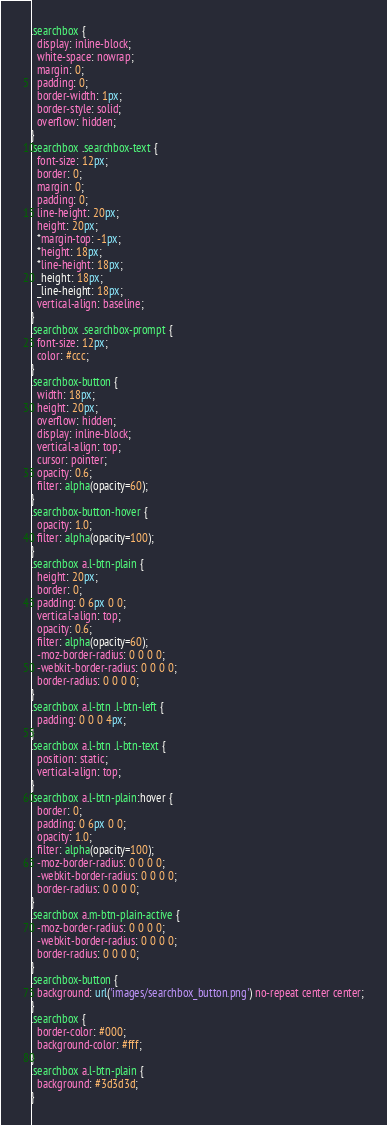Convert code to text. <code><loc_0><loc_0><loc_500><loc_500><_CSS_>.searchbox {
  display: inline-block;
  white-space: nowrap;
  margin: 0;
  padding: 0;
  border-width: 1px;
  border-style: solid;
  overflow: hidden;
}
.searchbox .searchbox-text {
  font-size: 12px;
  border: 0;
  margin: 0;
  padding: 0;
  line-height: 20px;
  height: 20px;
  *margin-top: -1px;
  *height: 18px;
  *line-height: 18px;
  _height: 18px;
  _line-height: 18px;
  vertical-align: baseline;
}
.searchbox .searchbox-prompt {
  font-size: 12px;
  color: #ccc;
}
.searchbox-button {
  width: 18px;
  height: 20px;
  overflow: hidden;
  display: inline-block;
  vertical-align: top;
  cursor: pointer;
  opacity: 0.6;
  filter: alpha(opacity=60);
}
.searchbox-button-hover {
  opacity: 1.0;
  filter: alpha(opacity=100);
}
.searchbox a.l-btn-plain {
  height: 20px;
  border: 0;
  padding: 0 6px 0 0;
  vertical-align: top;
  opacity: 0.6;
  filter: alpha(opacity=60);
  -moz-border-radius: 0 0 0 0;
  -webkit-border-radius: 0 0 0 0;
  border-radius: 0 0 0 0;
}
.searchbox a.l-btn .l-btn-left {
  padding: 0 0 0 4px;
}
.searchbox a.l-btn .l-btn-text {
  position: static;
  vertical-align: top;
}
.searchbox a.l-btn-plain:hover {
  border: 0;
  padding: 0 6px 0 0;
  opacity: 1.0;
  filter: alpha(opacity=100);
  -moz-border-radius: 0 0 0 0;
  -webkit-border-radius: 0 0 0 0;
  border-radius: 0 0 0 0;
}
.searchbox a.m-btn-plain-active {
  -moz-border-radius: 0 0 0 0;
  -webkit-border-radius: 0 0 0 0;
  border-radius: 0 0 0 0;
}
.searchbox-button {
  background: url('images/searchbox_button.png') no-repeat center center;
}
.searchbox {
  border-color: #000;
  background-color: #fff;
}
.searchbox a.l-btn-plain {
  background: #3d3d3d;
}
</code> 